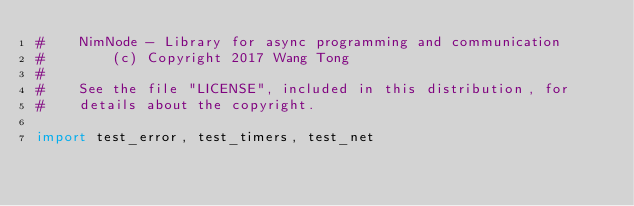Convert code to text. <code><loc_0><loc_0><loc_500><loc_500><_Nim_>#    NimNode - Library for async programming and communication
#        (c) Copyright 2017 Wang Tong
#
#    See the file "LICENSE", included in this distribution, for
#    details about the copyright.

import test_error, test_timers, test_net</code> 